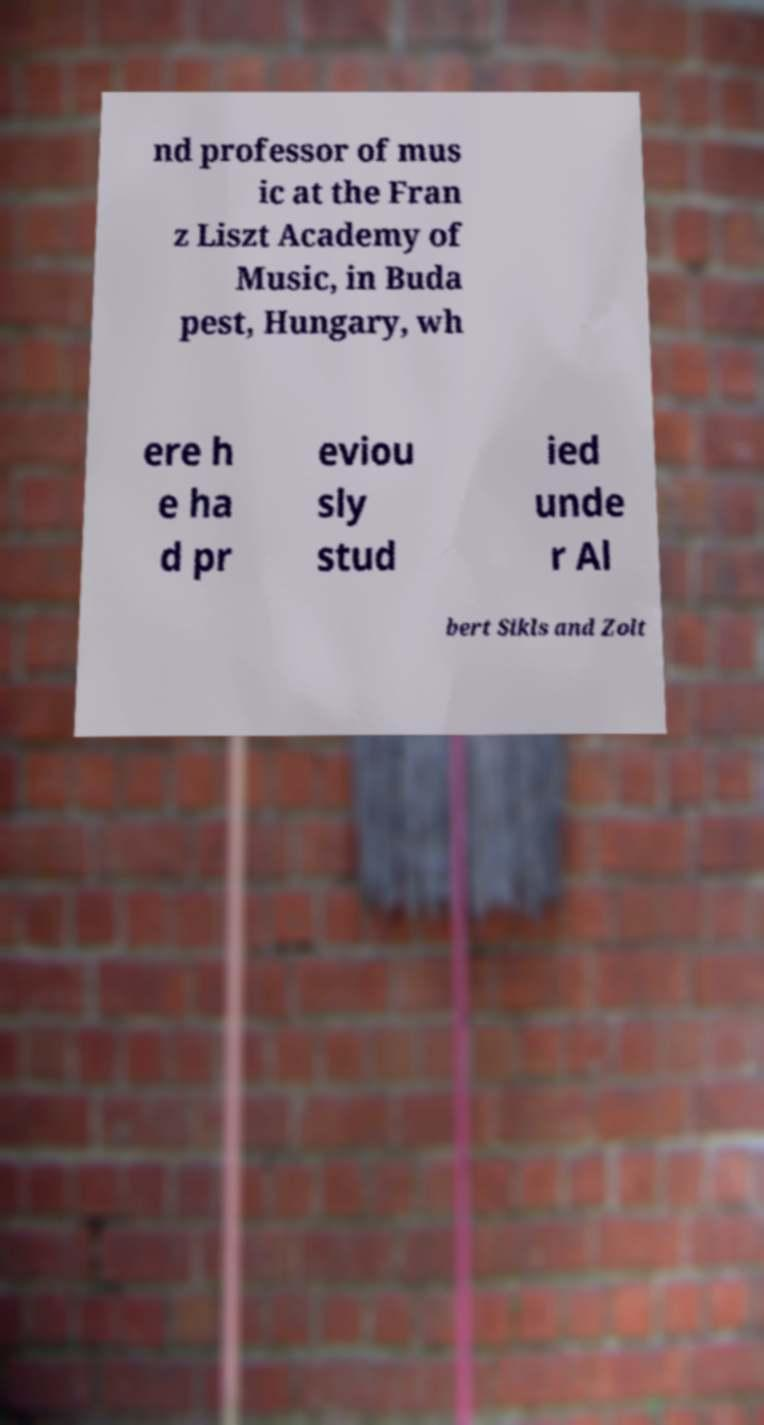Can you accurately transcribe the text from the provided image for me? nd professor of mus ic at the Fran z Liszt Academy of Music, in Buda pest, Hungary, wh ere h e ha d pr eviou sly stud ied unde r Al bert Sikls and Zolt 